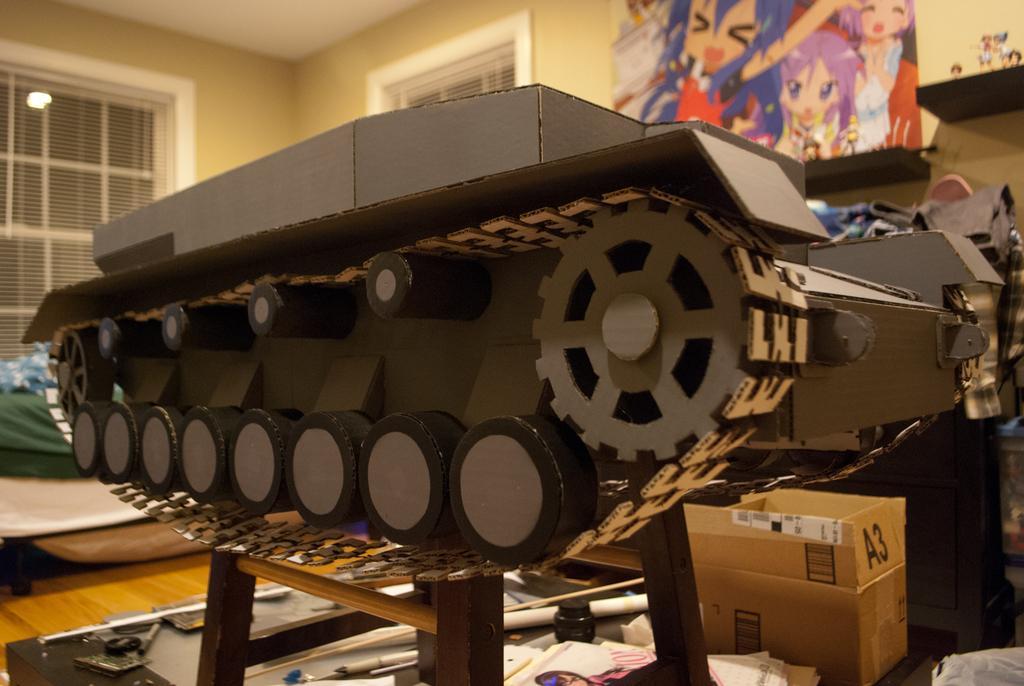Please provide a concise description of this image. We can see a machine on the table and we can see cardboard box, papers, stick, jar and objects on the floor. In the background we can see poster on the wall, toys on shelves, clothes, light and windows. 